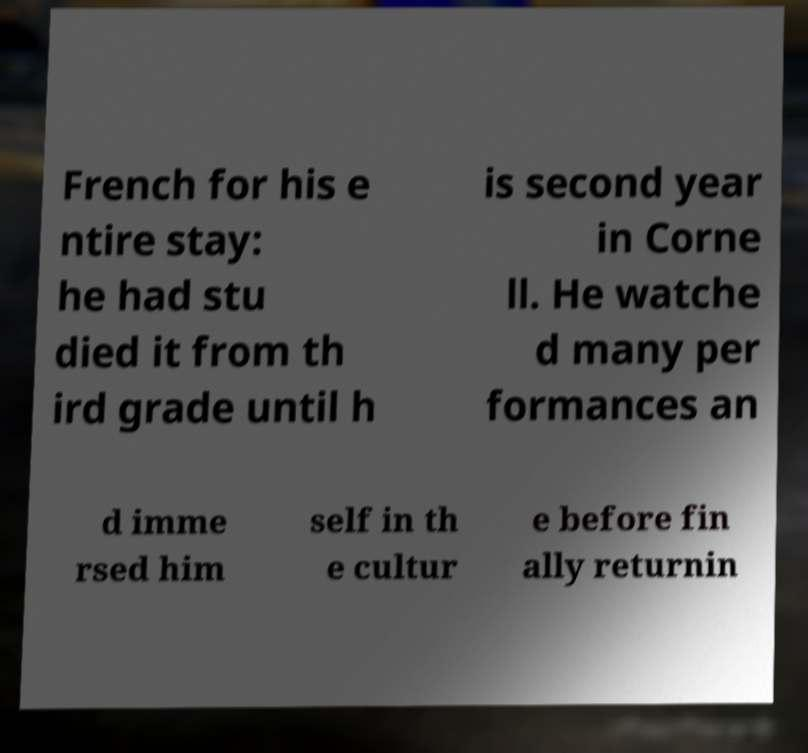Please identify and transcribe the text found in this image. French for his e ntire stay: he had stu died it from th ird grade until h is second year in Corne ll. He watche d many per formances an d imme rsed him self in th e cultur e before fin ally returnin 